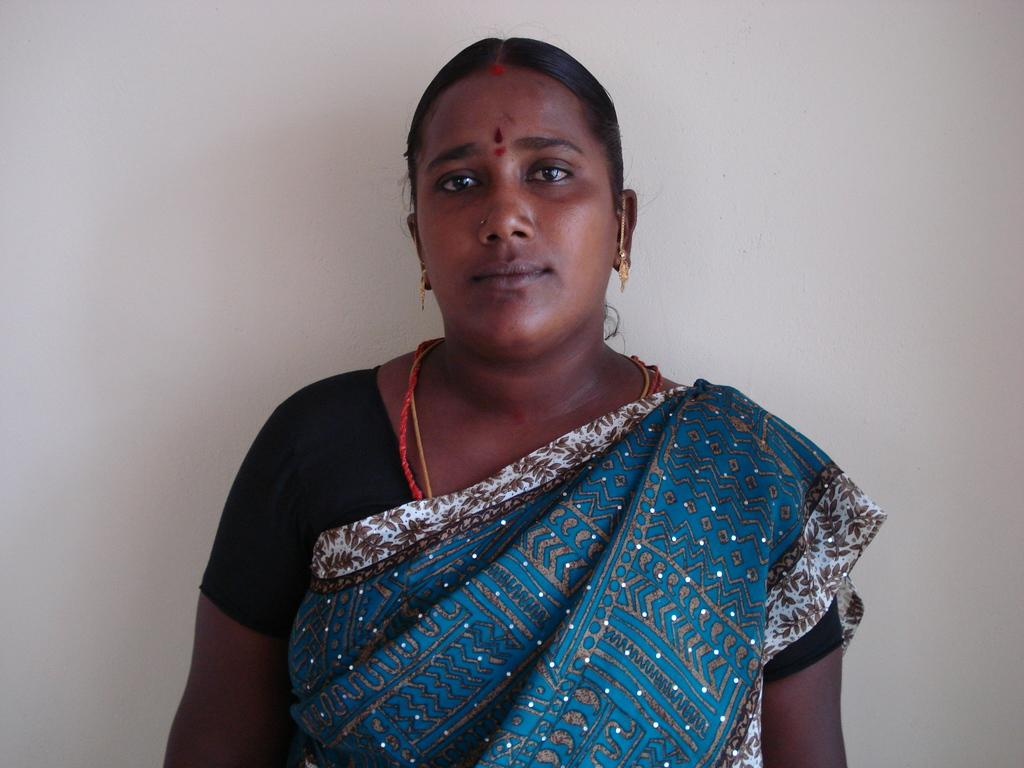What is the main subject in the foreground of the image? There is a woman in the foreground of the image. What is the woman doing in the image? The woman is standing in the image. What type of clothing is the woman wearing? The woman is wearing a saree in the image. What color is the background of the image? The background of the image is white. What type of brass instrument is the woman playing in the image? There is no brass instrument present in the image; the woman is simply standing and wearing a saree. 